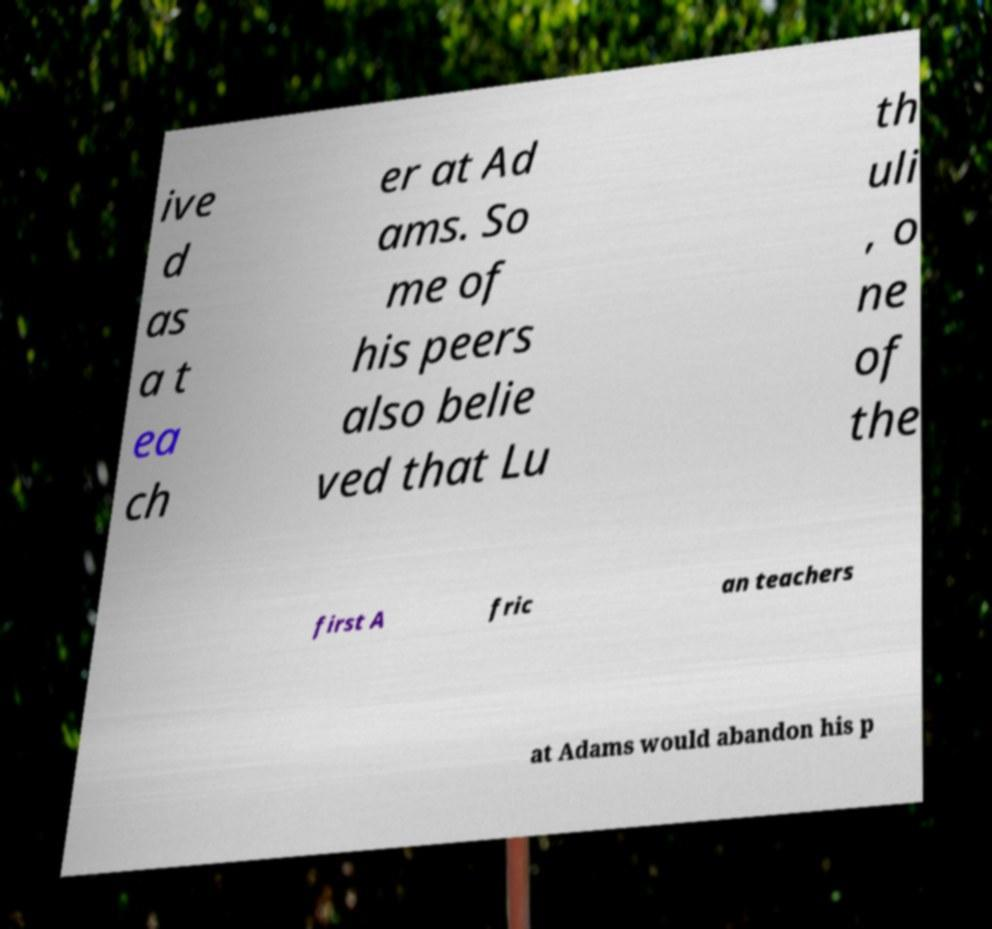Please identify and transcribe the text found in this image. ive d as a t ea ch er at Ad ams. So me of his peers also belie ved that Lu th uli , o ne of the first A fric an teachers at Adams would abandon his p 